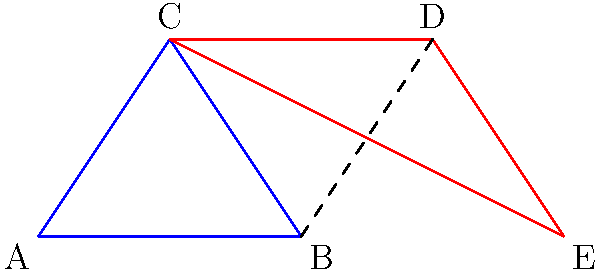In this cubist-inspired composition, two triangles are depicted. Identify which of the Congruence Theorems (SSS, SAS, ASA, AAS) could be used to prove that these triangles are congruent, given that $\overline{BC} \cong \overline{CD}$ and $\angle ACB \cong \angle DCE$. To determine which Congruence Theorem applies, let's analyze the given information and the properties of the triangles:

1. We are given that $\overline{BC} \cong \overline{CD}$, which means one side of each triangle is congruent.

2. We are also given that $\angle ACB \cong \angle DCE$, which means one angle in each triangle is congruent.

3. Observing the diagram, we can see that $\overline{BD}$ is a common side to both triangles. This means $\overline{AB} \cong \overline{DE}$.

4. Now we have:
   - One pair of congruent sides: $\overline{BC} \cong \overline{CD}$
   - One pair of congruent angles: $\angle ACB \cong \angle DCE$
   - Another pair of congruent sides: $\overline{AB} \cong \overline{DE}$

5. The congruent sides $\overline{AB}$ and $\overline{DE}$ are adjacent to the congruent angles $\angle ACB$ and $\angle DCE$ respectively.

6. This configuration matches the Side-Angle-Side (SAS) Congruence Theorem, which states that if two sides and the included angle of one triangle are congruent to two sides and the included angle of another triangle, then the triangles are congruent.

Therefore, the SAS Congruence Theorem can be used to prove that these triangles are congruent.
Answer: SAS (Side-Angle-Side) 